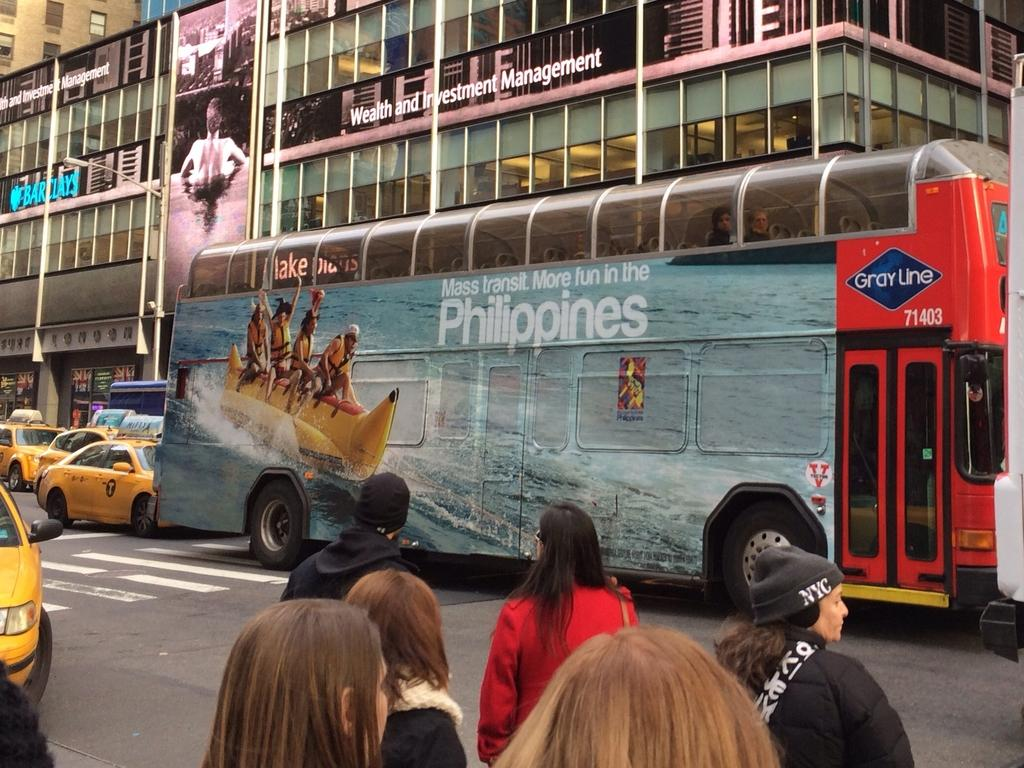Provide a one-sentence caption for the provided image. A large bus with Philippines on the side is on a road. 